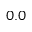Convert formula to latex. <formula><loc_0><loc_0><loc_500><loc_500>0 . 0</formula> 